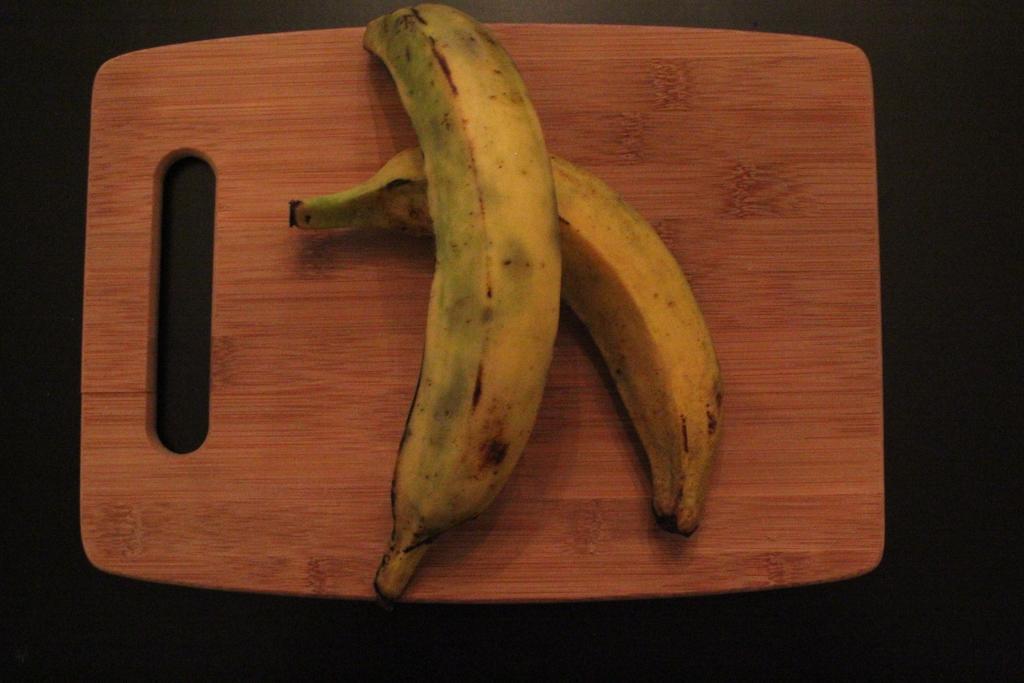Please provide a concise description of this image. This image consists of two bananas kept on a chopping board. The chopping board is made up of wood. At the bottom, there is floor. 